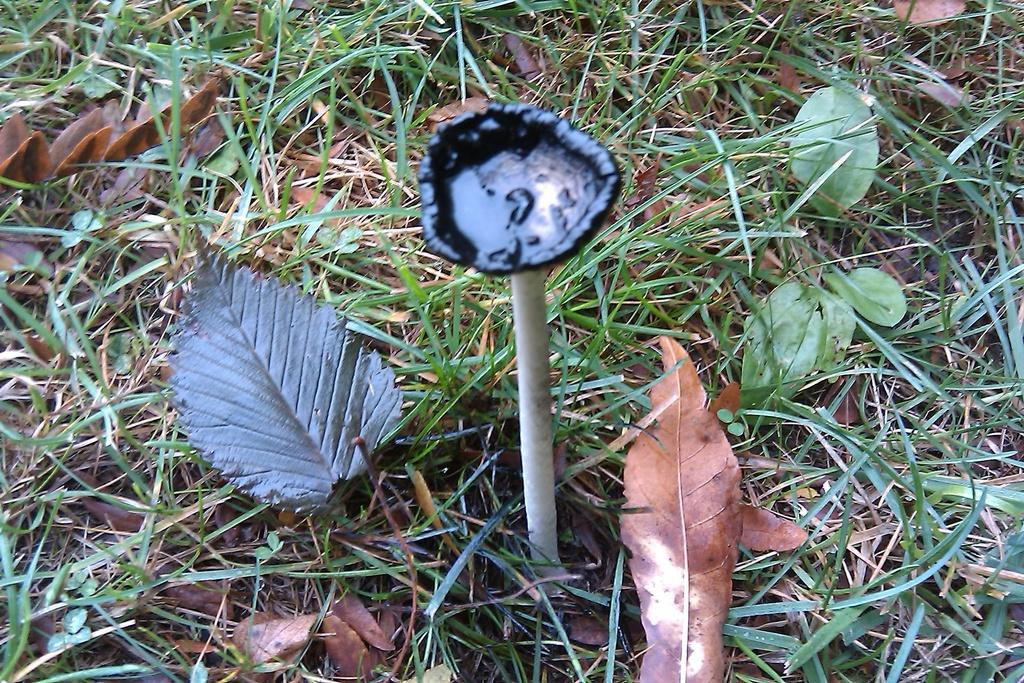What type of plant can be seen in the picture? There is a mushroom in the picture. What type of ground cover is present in the picture? There is grass on the floor in the picture. What additional natural elements can be seen in the picture? There are dry leaves in the picture. What is the rate of rabbits hopping in the picture? There are no rabbits present in the picture, so it is not possible to determine a rate of hopping. 